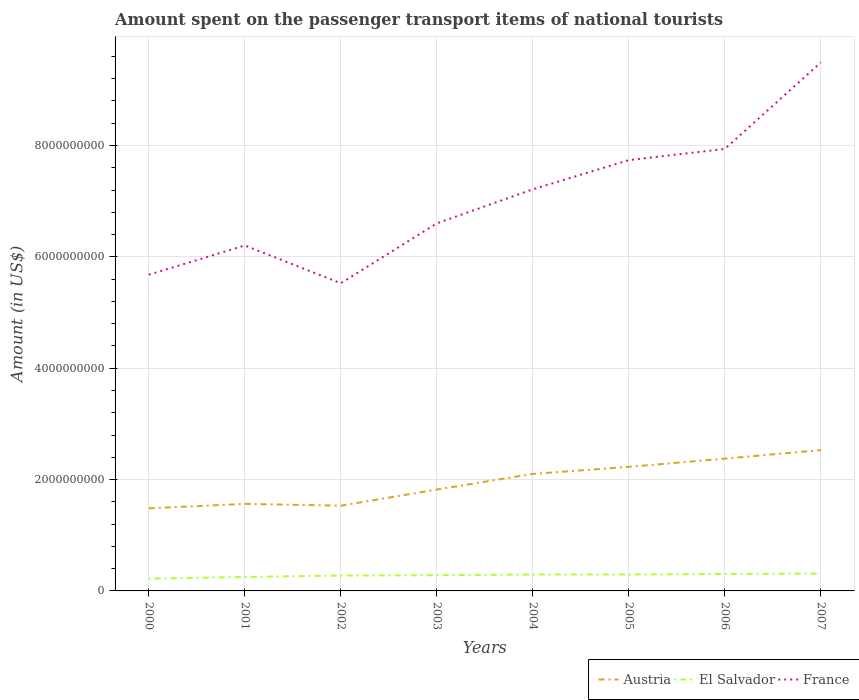How many different coloured lines are there?
Ensure brevity in your answer.  3. Is the number of lines equal to the number of legend labels?
Your response must be concise. Yes. Across all years, what is the maximum amount spent on the passenger transport items of national tourists in El Salvador?
Offer a very short reply. 2.20e+08. What is the total amount spent on the passenger transport items of national tourists in Austria in the graph?
Make the answer very short. -2.75e+08. What is the difference between the highest and the second highest amount spent on the passenger transport items of national tourists in France?
Your answer should be very brief. 3.97e+09. What is the difference between the highest and the lowest amount spent on the passenger transport items of national tourists in Austria?
Keep it short and to the point. 4. How many lines are there?
Give a very brief answer. 3. Are the values on the major ticks of Y-axis written in scientific E-notation?
Ensure brevity in your answer.  No. Where does the legend appear in the graph?
Make the answer very short. Bottom right. How many legend labels are there?
Make the answer very short. 3. What is the title of the graph?
Your response must be concise. Amount spent on the passenger transport items of national tourists. Does "Heavily indebted poor countries" appear as one of the legend labels in the graph?
Your answer should be compact. No. What is the Amount (in US$) in Austria in 2000?
Your answer should be very brief. 1.48e+09. What is the Amount (in US$) of El Salvador in 2000?
Provide a short and direct response. 2.20e+08. What is the Amount (in US$) of France in 2000?
Offer a very short reply. 5.68e+09. What is the Amount (in US$) of Austria in 2001?
Make the answer very short. 1.56e+09. What is the Amount (in US$) of El Salvador in 2001?
Provide a short and direct response. 2.51e+08. What is the Amount (in US$) of France in 2001?
Ensure brevity in your answer.  6.20e+09. What is the Amount (in US$) of Austria in 2002?
Your response must be concise. 1.53e+09. What is the Amount (in US$) in El Salvador in 2002?
Ensure brevity in your answer.  2.76e+08. What is the Amount (in US$) in France in 2002?
Provide a succinct answer. 5.53e+09. What is the Amount (in US$) in Austria in 2003?
Ensure brevity in your answer.  1.82e+09. What is the Amount (in US$) in El Salvador in 2003?
Provide a short and direct response. 2.82e+08. What is the Amount (in US$) in France in 2003?
Give a very brief answer. 6.60e+09. What is the Amount (in US$) of Austria in 2004?
Offer a very short reply. 2.10e+09. What is the Amount (in US$) in El Salvador in 2004?
Your answer should be very brief. 2.95e+08. What is the Amount (in US$) in France in 2004?
Offer a very short reply. 7.21e+09. What is the Amount (in US$) of Austria in 2005?
Your answer should be very brief. 2.23e+09. What is the Amount (in US$) of El Salvador in 2005?
Ensure brevity in your answer.  2.95e+08. What is the Amount (in US$) of France in 2005?
Your response must be concise. 7.74e+09. What is the Amount (in US$) in Austria in 2006?
Provide a short and direct response. 2.38e+09. What is the Amount (in US$) in El Salvador in 2006?
Ensure brevity in your answer.  3.04e+08. What is the Amount (in US$) in France in 2006?
Provide a succinct answer. 7.94e+09. What is the Amount (in US$) in Austria in 2007?
Your answer should be very brief. 2.53e+09. What is the Amount (in US$) of El Salvador in 2007?
Keep it short and to the point. 3.11e+08. What is the Amount (in US$) in France in 2007?
Give a very brief answer. 9.49e+09. Across all years, what is the maximum Amount (in US$) in Austria?
Your response must be concise. 2.53e+09. Across all years, what is the maximum Amount (in US$) of El Salvador?
Provide a short and direct response. 3.11e+08. Across all years, what is the maximum Amount (in US$) in France?
Your response must be concise. 9.49e+09. Across all years, what is the minimum Amount (in US$) in Austria?
Your response must be concise. 1.48e+09. Across all years, what is the minimum Amount (in US$) in El Salvador?
Provide a short and direct response. 2.20e+08. Across all years, what is the minimum Amount (in US$) of France?
Give a very brief answer. 5.53e+09. What is the total Amount (in US$) in Austria in the graph?
Your response must be concise. 1.56e+1. What is the total Amount (in US$) of El Salvador in the graph?
Your response must be concise. 2.23e+09. What is the total Amount (in US$) of France in the graph?
Offer a very short reply. 5.64e+1. What is the difference between the Amount (in US$) of Austria in 2000 and that in 2001?
Offer a very short reply. -8.00e+07. What is the difference between the Amount (in US$) in El Salvador in 2000 and that in 2001?
Keep it short and to the point. -3.10e+07. What is the difference between the Amount (in US$) in France in 2000 and that in 2001?
Provide a short and direct response. -5.25e+08. What is the difference between the Amount (in US$) in Austria in 2000 and that in 2002?
Make the answer very short. -4.80e+07. What is the difference between the Amount (in US$) of El Salvador in 2000 and that in 2002?
Provide a succinct answer. -5.60e+07. What is the difference between the Amount (in US$) in France in 2000 and that in 2002?
Make the answer very short. 1.53e+08. What is the difference between the Amount (in US$) in Austria in 2000 and that in 2003?
Your answer should be very brief. -3.38e+08. What is the difference between the Amount (in US$) in El Salvador in 2000 and that in 2003?
Your answer should be very brief. -6.20e+07. What is the difference between the Amount (in US$) of France in 2000 and that in 2003?
Ensure brevity in your answer.  -9.22e+08. What is the difference between the Amount (in US$) in Austria in 2000 and that in 2004?
Give a very brief answer. -6.18e+08. What is the difference between the Amount (in US$) of El Salvador in 2000 and that in 2004?
Offer a terse response. -7.50e+07. What is the difference between the Amount (in US$) of France in 2000 and that in 2004?
Offer a terse response. -1.53e+09. What is the difference between the Amount (in US$) in Austria in 2000 and that in 2005?
Provide a short and direct response. -7.45e+08. What is the difference between the Amount (in US$) of El Salvador in 2000 and that in 2005?
Offer a very short reply. -7.50e+07. What is the difference between the Amount (in US$) of France in 2000 and that in 2005?
Give a very brief answer. -2.06e+09. What is the difference between the Amount (in US$) in Austria in 2000 and that in 2006?
Provide a short and direct response. -8.93e+08. What is the difference between the Amount (in US$) in El Salvador in 2000 and that in 2006?
Give a very brief answer. -8.40e+07. What is the difference between the Amount (in US$) of France in 2000 and that in 2006?
Offer a terse response. -2.26e+09. What is the difference between the Amount (in US$) of Austria in 2000 and that in 2007?
Keep it short and to the point. -1.05e+09. What is the difference between the Amount (in US$) in El Salvador in 2000 and that in 2007?
Keep it short and to the point. -9.10e+07. What is the difference between the Amount (in US$) of France in 2000 and that in 2007?
Offer a very short reply. -3.81e+09. What is the difference between the Amount (in US$) in Austria in 2001 and that in 2002?
Your answer should be compact. 3.20e+07. What is the difference between the Amount (in US$) of El Salvador in 2001 and that in 2002?
Offer a terse response. -2.50e+07. What is the difference between the Amount (in US$) of France in 2001 and that in 2002?
Give a very brief answer. 6.78e+08. What is the difference between the Amount (in US$) of Austria in 2001 and that in 2003?
Your response must be concise. -2.58e+08. What is the difference between the Amount (in US$) of El Salvador in 2001 and that in 2003?
Your response must be concise. -3.10e+07. What is the difference between the Amount (in US$) of France in 2001 and that in 2003?
Make the answer very short. -3.97e+08. What is the difference between the Amount (in US$) in Austria in 2001 and that in 2004?
Provide a short and direct response. -5.38e+08. What is the difference between the Amount (in US$) in El Salvador in 2001 and that in 2004?
Provide a succinct answer. -4.40e+07. What is the difference between the Amount (in US$) in France in 2001 and that in 2004?
Keep it short and to the point. -1.01e+09. What is the difference between the Amount (in US$) of Austria in 2001 and that in 2005?
Your response must be concise. -6.65e+08. What is the difference between the Amount (in US$) in El Salvador in 2001 and that in 2005?
Make the answer very short. -4.40e+07. What is the difference between the Amount (in US$) of France in 2001 and that in 2005?
Ensure brevity in your answer.  -1.53e+09. What is the difference between the Amount (in US$) in Austria in 2001 and that in 2006?
Your answer should be compact. -8.13e+08. What is the difference between the Amount (in US$) of El Salvador in 2001 and that in 2006?
Your answer should be compact. -5.30e+07. What is the difference between the Amount (in US$) in France in 2001 and that in 2006?
Give a very brief answer. -1.73e+09. What is the difference between the Amount (in US$) of Austria in 2001 and that in 2007?
Your response must be concise. -9.66e+08. What is the difference between the Amount (in US$) of El Salvador in 2001 and that in 2007?
Your answer should be compact. -6.00e+07. What is the difference between the Amount (in US$) of France in 2001 and that in 2007?
Provide a short and direct response. -3.29e+09. What is the difference between the Amount (in US$) in Austria in 2002 and that in 2003?
Offer a terse response. -2.90e+08. What is the difference between the Amount (in US$) of El Salvador in 2002 and that in 2003?
Give a very brief answer. -6.00e+06. What is the difference between the Amount (in US$) in France in 2002 and that in 2003?
Give a very brief answer. -1.08e+09. What is the difference between the Amount (in US$) of Austria in 2002 and that in 2004?
Offer a terse response. -5.70e+08. What is the difference between the Amount (in US$) in El Salvador in 2002 and that in 2004?
Provide a short and direct response. -1.90e+07. What is the difference between the Amount (in US$) in France in 2002 and that in 2004?
Offer a terse response. -1.69e+09. What is the difference between the Amount (in US$) in Austria in 2002 and that in 2005?
Your answer should be very brief. -6.97e+08. What is the difference between the Amount (in US$) of El Salvador in 2002 and that in 2005?
Your response must be concise. -1.90e+07. What is the difference between the Amount (in US$) in France in 2002 and that in 2005?
Your answer should be compact. -2.21e+09. What is the difference between the Amount (in US$) in Austria in 2002 and that in 2006?
Offer a very short reply. -8.45e+08. What is the difference between the Amount (in US$) of El Salvador in 2002 and that in 2006?
Make the answer very short. -2.80e+07. What is the difference between the Amount (in US$) of France in 2002 and that in 2006?
Provide a short and direct response. -2.41e+09. What is the difference between the Amount (in US$) in Austria in 2002 and that in 2007?
Your answer should be compact. -9.98e+08. What is the difference between the Amount (in US$) in El Salvador in 2002 and that in 2007?
Offer a terse response. -3.50e+07. What is the difference between the Amount (in US$) in France in 2002 and that in 2007?
Provide a short and direct response. -3.97e+09. What is the difference between the Amount (in US$) in Austria in 2003 and that in 2004?
Provide a short and direct response. -2.80e+08. What is the difference between the Amount (in US$) of El Salvador in 2003 and that in 2004?
Offer a very short reply. -1.30e+07. What is the difference between the Amount (in US$) of France in 2003 and that in 2004?
Offer a terse response. -6.12e+08. What is the difference between the Amount (in US$) of Austria in 2003 and that in 2005?
Provide a short and direct response. -4.07e+08. What is the difference between the Amount (in US$) in El Salvador in 2003 and that in 2005?
Ensure brevity in your answer.  -1.30e+07. What is the difference between the Amount (in US$) in France in 2003 and that in 2005?
Provide a short and direct response. -1.14e+09. What is the difference between the Amount (in US$) in Austria in 2003 and that in 2006?
Offer a terse response. -5.55e+08. What is the difference between the Amount (in US$) of El Salvador in 2003 and that in 2006?
Your response must be concise. -2.20e+07. What is the difference between the Amount (in US$) in France in 2003 and that in 2006?
Ensure brevity in your answer.  -1.34e+09. What is the difference between the Amount (in US$) of Austria in 2003 and that in 2007?
Ensure brevity in your answer.  -7.08e+08. What is the difference between the Amount (in US$) of El Salvador in 2003 and that in 2007?
Offer a very short reply. -2.90e+07. What is the difference between the Amount (in US$) of France in 2003 and that in 2007?
Provide a succinct answer. -2.89e+09. What is the difference between the Amount (in US$) of Austria in 2004 and that in 2005?
Your answer should be compact. -1.27e+08. What is the difference between the Amount (in US$) of El Salvador in 2004 and that in 2005?
Your answer should be compact. 0. What is the difference between the Amount (in US$) in France in 2004 and that in 2005?
Offer a terse response. -5.24e+08. What is the difference between the Amount (in US$) in Austria in 2004 and that in 2006?
Provide a succinct answer. -2.75e+08. What is the difference between the Amount (in US$) in El Salvador in 2004 and that in 2006?
Your response must be concise. -9.00e+06. What is the difference between the Amount (in US$) of France in 2004 and that in 2006?
Keep it short and to the point. -7.25e+08. What is the difference between the Amount (in US$) in Austria in 2004 and that in 2007?
Your answer should be very brief. -4.28e+08. What is the difference between the Amount (in US$) in El Salvador in 2004 and that in 2007?
Provide a short and direct response. -1.60e+07. What is the difference between the Amount (in US$) of France in 2004 and that in 2007?
Your response must be concise. -2.28e+09. What is the difference between the Amount (in US$) in Austria in 2005 and that in 2006?
Provide a short and direct response. -1.48e+08. What is the difference between the Amount (in US$) in El Salvador in 2005 and that in 2006?
Keep it short and to the point. -9.00e+06. What is the difference between the Amount (in US$) of France in 2005 and that in 2006?
Your answer should be very brief. -2.01e+08. What is the difference between the Amount (in US$) of Austria in 2005 and that in 2007?
Give a very brief answer. -3.01e+08. What is the difference between the Amount (in US$) in El Salvador in 2005 and that in 2007?
Make the answer very short. -1.60e+07. What is the difference between the Amount (in US$) in France in 2005 and that in 2007?
Offer a very short reply. -1.76e+09. What is the difference between the Amount (in US$) of Austria in 2006 and that in 2007?
Give a very brief answer. -1.53e+08. What is the difference between the Amount (in US$) in El Salvador in 2006 and that in 2007?
Your answer should be compact. -7.00e+06. What is the difference between the Amount (in US$) of France in 2006 and that in 2007?
Make the answer very short. -1.55e+09. What is the difference between the Amount (in US$) of Austria in 2000 and the Amount (in US$) of El Salvador in 2001?
Keep it short and to the point. 1.23e+09. What is the difference between the Amount (in US$) of Austria in 2000 and the Amount (in US$) of France in 2001?
Your response must be concise. -4.72e+09. What is the difference between the Amount (in US$) in El Salvador in 2000 and the Amount (in US$) in France in 2001?
Your response must be concise. -5.98e+09. What is the difference between the Amount (in US$) of Austria in 2000 and the Amount (in US$) of El Salvador in 2002?
Keep it short and to the point. 1.21e+09. What is the difference between the Amount (in US$) of Austria in 2000 and the Amount (in US$) of France in 2002?
Offer a very short reply. -4.04e+09. What is the difference between the Amount (in US$) in El Salvador in 2000 and the Amount (in US$) in France in 2002?
Ensure brevity in your answer.  -5.31e+09. What is the difference between the Amount (in US$) of Austria in 2000 and the Amount (in US$) of El Salvador in 2003?
Offer a terse response. 1.20e+09. What is the difference between the Amount (in US$) of Austria in 2000 and the Amount (in US$) of France in 2003?
Give a very brief answer. -5.12e+09. What is the difference between the Amount (in US$) in El Salvador in 2000 and the Amount (in US$) in France in 2003?
Offer a very short reply. -6.38e+09. What is the difference between the Amount (in US$) of Austria in 2000 and the Amount (in US$) of El Salvador in 2004?
Provide a short and direct response. 1.19e+09. What is the difference between the Amount (in US$) in Austria in 2000 and the Amount (in US$) in France in 2004?
Keep it short and to the point. -5.73e+09. What is the difference between the Amount (in US$) in El Salvador in 2000 and the Amount (in US$) in France in 2004?
Keep it short and to the point. -6.99e+09. What is the difference between the Amount (in US$) of Austria in 2000 and the Amount (in US$) of El Salvador in 2005?
Provide a short and direct response. 1.19e+09. What is the difference between the Amount (in US$) in Austria in 2000 and the Amount (in US$) in France in 2005?
Ensure brevity in your answer.  -6.25e+09. What is the difference between the Amount (in US$) of El Salvador in 2000 and the Amount (in US$) of France in 2005?
Your response must be concise. -7.52e+09. What is the difference between the Amount (in US$) of Austria in 2000 and the Amount (in US$) of El Salvador in 2006?
Make the answer very short. 1.18e+09. What is the difference between the Amount (in US$) of Austria in 2000 and the Amount (in US$) of France in 2006?
Offer a very short reply. -6.46e+09. What is the difference between the Amount (in US$) of El Salvador in 2000 and the Amount (in US$) of France in 2006?
Keep it short and to the point. -7.72e+09. What is the difference between the Amount (in US$) in Austria in 2000 and the Amount (in US$) in El Salvador in 2007?
Your response must be concise. 1.17e+09. What is the difference between the Amount (in US$) in Austria in 2000 and the Amount (in US$) in France in 2007?
Your answer should be very brief. -8.01e+09. What is the difference between the Amount (in US$) of El Salvador in 2000 and the Amount (in US$) of France in 2007?
Your response must be concise. -9.27e+09. What is the difference between the Amount (in US$) in Austria in 2001 and the Amount (in US$) in El Salvador in 2002?
Give a very brief answer. 1.29e+09. What is the difference between the Amount (in US$) of Austria in 2001 and the Amount (in US$) of France in 2002?
Provide a succinct answer. -3.96e+09. What is the difference between the Amount (in US$) of El Salvador in 2001 and the Amount (in US$) of France in 2002?
Keep it short and to the point. -5.28e+09. What is the difference between the Amount (in US$) in Austria in 2001 and the Amount (in US$) in El Salvador in 2003?
Offer a very short reply. 1.28e+09. What is the difference between the Amount (in US$) in Austria in 2001 and the Amount (in US$) in France in 2003?
Provide a short and direct response. -5.04e+09. What is the difference between the Amount (in US$) in El Salvador in 2001 and the Amount (in US$) in France in 2003?
Provide a short and direct response. -6.35e+09. What is the difference between the Amount (in US$) of Austria in 2001 and the Amount (in US$) of El Salvador in 2004?
Your answer should be very brief. 1.27e+09. What is the difference between the Amount (in US$) of Austria in 2001 and the Amount (in US$) of France in 2004?
Your answer should be compact. -5.65e+09. What is the difference between the Amount (in US$) of El Salvador in 2001 and the Amount (in US$) of France in 2004?
Give a very brief answer. -6.96e+09. What is the difference between the Amount (in US$) in Austria in 2001 and the Amount (in US$) in El Salvador in 2005?
Your answer should be compact. 1.27e+09. What is the difference between the Amount (in US$) in Austria in 2001 and the Amount (in US$) in France in 2005?
Give a very brief answer. -6.17e+09. What is the difference between the Amount (in US$) of El Salvador in 2001 and the Amount (in US$) of France in 2005?
Give a very brief answer. -7.49e+09. What is the difference between the Amount (in US$) in Austria in 2001 and the Amount (in US$) in El Salvador in 2006?
Ensure brevity in your answer.  1.26e+09. What is the difference between the Amount (in US$) of Austria in 2001 and the Amount (in US$) of France in 2006?
Keep it short and to the point. -6.38e+09. What is the difference between the Amount (in US$) in El Salvador in 2001 and the Amount (in US$) in France in 2006?
Your response must be concise. -7.69e+09. What is the difference between the Amount (in US$) of Austria in 2001 and the Amount (in US$) of El Salvador in 2007?
Ensure brevity in your answer.  1.25e+09. What is the difference between the Amount (in US$) in Austria in 2001 and the Amount (in US$) in France in 2007?
Provide a succinct answer. -7.93e+09. What is the difference between the Amount (in US$) of El Salvador in 2001 and the Amount (in US$) of France in 2007?
Ensure brevity in your answer.  -9.24e+09. What is the difference between the Amount (in US$) in Austria in 2002 and the Amount (in US$) in El Salvador in 2003?
Provide a short and direct response. 1.25e+09. What is the difference between the Amount (in US$) in Austria in 2002 and the Amount (in US$) in France in 2003?
Ensure brevity in your answer.  -5.07e+09. What is the difference between the Amount (in US$) in El Salvador in 2002 and the Amount (in US$) in France in 2003?
Your answer should be compact. -6.32e+09. What is the difference between the Amount (in US$) in Austria in 2002 and the Amount (in US$) in El Salvador in 2004?
Provide a short and direct response. 1.24e+09. What is the difference between the Amount (in US$) in Austria in 2002 and the Amount (in US$) in France in 2004?
Make the answer very short. -5.68e+09. What is the difference between the Amount (in US$) of El Salvador in 2002 and the Amount (in US$) of France in 2004?
Ensure brevity in your answer.  -6.94e+09. What is the difference between the Amount (in US$) of Austria in 2002 and the Amount (in US$) of El Salvador in 2005?
Give a very brief answer. 1.24e+09. What is the difference between the Amount (in US$) in Austria in 2002 and the Amount (in US$) in France in 2005?
Provide a succinct answer. -6.21e+09. What is the difference between the Amount (in US$) in El Salvador in 2002 and the Amount (in US$) in France in 2005?
Your answer should be compact. -7.46e+09. What is the difference between the Amount (in US$) of Austria in 2002 and the Amount (in US$) of El Salvador in 2006?
Provide a succinct answer. 1.23e+09. What is the difference between the Amount (in US$) in Austria in 2002 and the Amount (in US$) in France in 2006?
Ensure brevity in your answer.  -6.41e+09. What is the difference between the Amount (in US$) in El Salvador in 2002 and the Amount (in US$) in France in 2006?
Your response must be concise. -7.66e+09. What is the difference between the Amount (in US$) of Austria in 2002 and the Amount (in US$) of El Salvador in 2007?
Provide a short and direct response. 1.22e+09. What is the difference between the Amount (in US$) of Austria in 2002 and the Amount (in US$) of France in 2007?
Offer a terse response. -7.96e+09. What is the difference between the Amount (in US$) in El Salvador in 2002 and the Amount (in US$) in France in 2007?
Offer a terse response. -9.22e+09. What is the difference between the Amount (in US$) of Austria in 2003 and the Amount (in US$) of El Salvador in 2004?
Your answer should be very brief. 1.53e+09. What is the difference between the Amount (in US$) of Austria in 2003 and the Amount (in US$) of France in 2004?
Provide a succinct answer. -5.39e+09. What is the difference between the Amount (in US$) of El Salvador in 2003 and the Amount (in US$) of France in 2004?
Make the answer very short. -6.93e+09. What is the difference between the Amount (in US$) of Austria in 2003 and the Amount (in US$) of El Salvador in 2005?
Your answer should be compact. 1.53e+09. What is the difference between the Amount (in US$) of Austria in 2003 and the Amount (in US$) of France in 2005?
Provide a succinct answer. -5.92e+09. What is the difference between the Amount (in US$) in El Salvador in 2003 and the Amount (in US$) in France in 2005?
Your answer should be compact. -7.46e+09. What is the difference between the Amount (in US$) in Austria in 2003 and the Amount (in US$) in El Salvador in 2006?
Your response must be concise. 1.52e+09. What is the difference between the Amount (in US$) in Austria in 2003 and the Amount (in US$) in France in 2006?
Offer a very short reply. -6.12e+09. What is the difference between the Amount (in US$) in El Salvador in 2003 and the Amount (in US$) in France in 2006?
Offer a terse response. -7.66e+09. What is the difference between the Amount (in US$) in Austria in 2003 and the Amount (in US$) in El Salvador in 2007?
Your answer should be very brief. 1.51e+09. What is the difference between the Amount (in US$) of Austria in 2003 and the Amount (in US$) of France in 2007?
Your answer should be very brief. -7.67e+09. What is the difference between the Amount (in US$) of El Salvador in 2003 and the Amount (in US$) of France in 2007?
Provide a short and direct response. -9.21e+09. What is the difference between the Amount (in US$) of Austria in 2004 and the Amount (in US$) of El Salvador in 2005?
Give a very brief answer. 1.81e+09. What is the difference between the Amount (in US$) in Austria in 2004 and the Amount (in US$) in France in 2005?
Provide a short and direct response. -5.64e+09. What is the difference between the Amount (in US$) of El Salvador in 2004 and the Amount (in US$) of France in 2005?
Your response must be concise. -7.44e+09. What is the difference between the Amount (in US$) in Austria in 2004 and the Amount (in US$) in El Salvador in 2006?
Your answer should be compact. 1.80e+09. What is the difference between the Amount (in US$) in Austria in 2004 and the Amount (in US$) in France in 2006?
Keep it short and to the point. -5.84e+09. What is the difference between the Amount (in US$) in El Salvador in 2004 and the Amount (in US$) in France in 2006?
Your response must be concise. -7.64e+09. What is the difference between the Amount (in US$) in Austria in 2004 and the Amount (in US$) in El Salvador in 2007?
Provide a short and direct response. 1.79e+09. What is the difference between the Amount (in US$) of Austria in 2004 and the Amount (in US$) of France in 2007?
Offer a terse response. -7.39e+09. What is the difference between the Amount (in US$) in El Salvador in 2004 and the Amount (in US$) in France in 2007?
Give a very brief answer. -9.20e+09. What is the difference between the Amount (in US$) of Austria in 2005 and the Amount (in US$) of El Salvador in 2006?
Make the answer very short. 1.92e+09. What is the difference between the Amount (in US$) of Austria in 2005 and the Amount (in US$) of France in 2006?
Provide a short and direct response. -5.71e+09. What is the difference between the Amount (in US$) in El Salvador in 2005 and the Amount (in US$) in France in 2006?
Provide a short and direct response. -7.64e+09. What is the difference between the Amount (in US$) in Austria in 2005 and the Amount (in US$) in El Salvador in 2007?
Your response must be concise. 1.92e+09. What is the difference between the Amount (in US$) of Austria in 2005 and the Amount (in US$) of France in 2007?
Keep it short and to the point. -7.26e+09. What is the difference between the Amount (in US$) of El Salvador in 2005 and the Amount (in US$) of France in 2007?
Keep it short and to the point. -9.20e+09. What is the difference between the Amount (in US$) in Austria in 2006 and the Amount (in US$) in El Salvador in 2007?
Provide a short and direct response. 2.06e+09. What is the difference between the Amount (in US$) of Austria in 2006 and the Amount (in US$) of France in 2007?
Ensure brevity in your answer.  -7.12e+09. What is the difference between the Amount (in US$) of El Salvador in 2006 and the Amount (in US$) of France in 2007?
Give a very brief answer. -9.19e+09. What is the average Amount (in US$) in Austria per year?
Your answer should be very brief. 1.95e+09. What is the average Amount (in US$) of El Salvador per year?
Your response must be concise. 2.79e+08. What is the average Amount (in US$) in France per year?
Make the answer very short. 7.05e+09. In the year 2000, what is the difference between the Amount (in US$) in Austria and Amount (in US$) in El Salvador?
Ensure brevity in your answer.  1.26e+09. In the year 2000, what is the difference between the Amount (in US$) in Austria and Amount (in US$) in France?
Keep it short and to the point. -4.20e+09. In the year 2000, what is the difference between the Amount (in US$) in El Salvador and Amount (in US$) in France?
Give a very brief answer. -5.46e+09. In the year 2001, what is the difference between the Amount (in US$) in Austria and Amount (in US$) in El Salvador?
Offer a terse response. 1.31e+09. In the year 2001, what is the difference between the Amount (in US$) in Austria and Amount (in US$) in France?
Your answer should be compact. -4.64e+09. In the year 2001, what is the difference between the Amount (in US$) of El Salvador and Amount (in US$) of France?
Provide a short and direct response. -5.95e+09. In the year 2002, what is the difference between the Amount (in US$) of Austria and Amount (in US$) of El Salvador?
Give a very brief answer. 1.26e+09. In the year 2002, what is the difference between the Amount (in US$) in Austria and Amount (in US$) in France?
Ensure brevity in your answer.  -4.00e+09. In the year 2002, what is the difference between the Amount (in US$) in El Salvador and Amount (in US$) in France?
Offer a terse response. -5.25e+09. In the year 2003, what is the difference between the Amount (in US$) in Austria and Amount (in US$) in El Salvador?
Offer a very short reply. 1.54e+09. In the year 2003, what is the difference between the Amount (in US$) in Austria and Amount (in US$) in France?
Offer a very short reply. -4.78e+09. In the year 2003, what is the difference between the Amount (in US$) of El Salvador and Amount (in US$) of France?
Provide a succinct answer. -6.32e+09. In the year 2004, what is the difference between the Amount (in US$) of Austria and Amount (in US$) of El Salvador?
Your answer should be compact. 1.81e+09. In the year 2004, what is the difference between the Amount (in US$) in Austria and Amount (in US$) in France?
Your answer should be very brief. -5.11e+09. In the year 2004, what is the difference between the Amount (in US$) of El Salvador and Amount (in US$) of France?
Your response must be concise. -6.92e+09. In the year 2005, what is the difference between the Amount (in US$) of Austria and Amount (in US$) of El Salvador?
Provide a short and direct response. 1.93e+09. In the year 2005, what is the difference between the Amount (in US$) in Austria and Amount (in US$) in France?
Provide a succinct answer. -5.51e+09. In the year 2005, what is the difference between the Amount (in US$) in El Salvador and Amount (in US$) in France?
Give a very brief answer. -7.44e+09. In the year 2006, what is the difference between the Amount (in US$) of Austria and Amount (in US$) of El Salvador?
Your answer should be very brief. 2.07e+09. In the year 2006, what is the difference between the Amount (in US$) in Austria and Amount (in US$) in France?
Provide a short and direct response. -5.56e+09. In the year 2006, what is the difference between the Amount (in US$) in El Salvador and Amount (in US$) in France?
Make the answer very short. -7.63e+09. In the year 2007, what is the difference between the Amount (in US$) of Austria and Amount (in US$) of El Salvador?
Offer a very short reply. 2.22e+09. In the year 2007, what is the difference between the Amount (in US$) in Austria and Amount (in US$) in France?
Provide a short and direct response. -6.96e+09. In the year 2007, what is the difference between the Amount (in US$) in El Salvador and Amount (in US$) in France?
Your answer should be very brief. -9.18e+09. What is the ratio of the Amount (in US$) of Austria in 2000 to that in 2001?
Give a very brief answer. 0.95. What is the ratio of the Amount (in US$) of El Salvador in 2000 to that in 2001?
Ensure brevity in your answer.  0.88. What is the ratio of the Amount (in US$) of France in 2000 to that in 2001?
Provide a succinct answer. 0.92. What is the ratio of the Amount (in US$) of Austria in 2000 to that in 2002?
Your answer should be compact. 0.97. What is the ratio of the Amount (in US$) of El Salvador in 2000 to that in 2002?
Ensure brevity in your answer.  0.8. What is the ratio of the Amount (in US$) in France in 2000 to that in 2002?
Offer a terse response. 1.03. What is the ratio of the Amount (in US$) in Austria in 2000 to that in 2003?
Offer a terse response. 0.81. What is the ratio of the Amount (in US$) of El Salvador in 2000 to that in 2003?
Make the answer very short. 0.78. What is the ratio of the Amount (in US$) in France in 2000 to that in 2003?
Ensure brevity in your answer.  0.86. What is the ratio of the Amount (in US$) in Austria in 2000 to that in 2004?
Provide a short and direct response. 0.71. What is the ratio of the Amount (in US$) of El Salvador in 2000 to that in 2004?
Your answer should be very brief. 0.75. What is the ratio of the Amount (in US$) in France in 2000 to that in 2004?
Your response must be concise. 0.79. What is the ratio of the Amount (in US$) of Austria in 2000 to that in 2005?
Your answer should be compact. 0.67. What is the ratio of the Amount (in US$) of El Salvador in 2000 to that in 2005?
Offer a very short reply. 0.75. What is the ratio of the Amount (in US$) in France in 2000 to that in 2005?
Provide a succinct answer. 0.73. What is the ratio of the Amount (in US$) of Austria in 2000 to that in 2006?
Your response must be concise. 0.62. What is the ratio of the Amount (in US$) in El Salvador in 2000 to that in 2006?
Ensure brevity in your answer.  0.72. What is the ratio of the Amount (in US$) in France in 2000 to that in 2006?
Make the answer very short. 0.72. What is the ratio of the Amount (in US$) of Austria in 2000 to that in 2007?
Give a very brief answer. 0.59. What is the ratio of the Amount (in US$) in El Salvador in 2000 to that in 2007?
Make the answer very short. 0.71. What is the ratio of the Amount (in US$) of France in 2000 to that in 2007?
Your answer should be compact. 0.6. What is the ratio of the Amount (in US$) in Austria in 2001 to that in 2002?
Your response must be concise. 1.02. What is the ratio of the Amount (in US$) of El Salvador in 2001 to that in 2002?
Ensure brevity in your answer.  0.91. What is the ratio of the Amount (in US$) in France in 2001 to that in 2002?
Your answer should be compact. 1.12. What is the ratio of the Amount (in US$) in Austria in 2001 to that in 2003?
Give a very brief answer. 0.86. What is the ratio of the Amount (in US$) in El Salvador in 2001 to that in 2003?
Provide a short and direct response. 0.89. What is the ratio of the Amount (in US$) of France in 2001 to that in 2003?
Give a very brief answer. 0.94. What is the ratio of the Amount (in US$) in Austria in 2001 to that in 2004?
Your response must be concise. 0.74. What is the ratio of the Amount (in US$) in El Salvador in 2001 to that in 2004?
Offer a terse response. 0.85. What is the ratio of the Amount (in US$) of France in 2001 to that in 2004?
Offer a very short reply. 0.86. What is the ratio of the Amount (in US$) in Austria in 2001 to that in 2005?
Your response must be concise. 0.7. What is the ratio of the Amount (in US$) in El Salvador in 2001 to that in 2005?
Provide a short and direct response. 0.85. What is the ratio of the Amount (in US$) of France in 2001 to that in 2005?
Ensure brevity in your answer.  0.8. What is the ratio of the Amount (in US$) of Austria in 2001 to that in 2006?
Provide a short and direct response. 0.66. What is the ratio of the Amount (in US$) in El Salvador in 2001 to that in 2006?
Your answer should be compact. 0.83. What is the ratio of the Amount (in US$) of France in 2001 to that in 2006?
Your response must be concise. 0.78. What is the ratio of the Amount (in US$) in Austria in 2001 to that in 2007?
Your answer should be compact. 0.62. What is the ratio of the Amount (in US$) of El Salvador in 2001 to that in 2007?
Provide a short and direct response. 0.81. What is the ratio of the Amount (in US$) of France in 2001 to that in 2007?
Offer a very short reply. 0.65. What is the ratio of the Amount (in US$) in Austria in 2002 to that in 2003?
Keep it short and to the point. 0.84. What is the ratio of the Amount (in US$) in El Salvador in 2002 to that in 2003?
Your response must be concise. 0.98. What is the ratio of the Amount (in US$) of France in 2002 to that in 2003?
Provide a succinct answer. 0.84. What is the ratio of the Amount (in US$) of Austria in 2002 to that in 2004?
Offer a terse response. 0.73. What is the ratio of the Amount (in US$) of El Salvador in 2002 to that in 2004?
Offer a very short reply. 0.94. What is the ratio of the Amount (in US$) of France in 2002 to that in 2004?
Provide a succinct answer. 0.77. What is the ratio of the Amount (in US$) of Austria in 2002 to that in 2005?
Give a very brief answer. 0.69. What is the ratio of the Amount (in US$) of El Salvador in 2002 to that in 2005?
Offer a very short reply. 0.94. What is the ratio of the Amount (in US$) of France in 2002 to that in 2005?
Provide a succinct answer. 0.71. What is the ratio of the Amount (in US$) in Austria in 2002 to that in 2006?
Your answer should be very brief. 0.64. What is the ratio of the Amount (in US$) in El Salvador in 2002 to that in 2006?
Your answer should be very brief. 0.91. What is the ratio of the Amount (in US$) of France in 2002 to that in 2006?
Provide a short and direct response. 0.7. What is the ratio of the Amount (in US$) of Austria in 2002 to that in 2007?
Provide a succinct answer. 0.61. What is the ratio of the Amount (in US$) of El Salvador in 2002 to that in 2007?
Keep it short and to the point. 0.89. What is the ratio of the Amount (in US$) of France in 2002 to that in 2007?
Offer a terse response. 0.58. What is the ratio of the Amount (in US$) in Austria in 2003 to that in 2004?
Make the answer very short. 0.87. What is the ratio of the Amount (in US$) in El Salvador in 2003 to that in 2004?
Provide a succinct answer. 0.96. What is the ratio of the Amount (in US$) of France in 2003 to that in 2004?
Your answer should be compact. 0.92. What is the ratio of the Amount (in US$) of Austria in 2003 to that in 2005?
Give a very brief answer. 0.82. What is the ratio of the Amount (in US$) of El Salvador in 2003 to that in 2005?
Ensure brevity in your answer.  0.96. What is the ratio of the Amount (in US$) of France in 2003 to that in 2005?
Your answer should be compact. 0.85. What is the ratio of the Amount (in US$) of Austria in 2003 to that in 2006?
Your answer should be very brief. 0.77. What is the ratio of the Amount (in US$) in El Salvador in 2003 to that in 2006?
Provide a short and direct response. 0.93. What is the ratio of the Amount (in US$) in France in 2003 to that in 2006?
Offer a very short reply. 0.83. What is the ratio of the Amount (in US$) in Austria in 2003 to that in 2007?
Provide a succinct answer. 0.72. What is the ratio of the Amount (in US$) in El Salvador in 2003 to that in 2007?
Offer a terse response. 0.91. What is the ratio of the Amount (in US$) of France in 2003 to that in 2007?
Ensure brevity in your answer.  0.7. What is the ratio of the Amount (in US$) of Austria in 2004 to that in 2005?
Your response must be concise. 0.94. What is the ratio of the Amount (in US$) in El Salvador in 2004 to that in 2005?
Offer a terse response. 1. What is the ratio of the Amount (in US$) in France in 2004 to that in 2005?
Provide a succinct answer. 0.93. What is the ratio of the Amount (in US$) in Austria in 2004 to that in 2006?
Provide a short and direct response. 0.88. What is the ratio of the Amount (in US$) of El Salvador in 2004 to that in 2006?
Give a very brief answer. 0.97. What is the ratio of the Amount (in US$) in France in 2004 to that in 2006?
Give a very brief answer. 0.91. What is the ratio of the Amount (in US$) of Austria in 2004 to that in 2007?
Give a very brief answer. 0.83. What is the ratio of the Amount (in US$) in El Salvador in 2004 to that in 2007?
Offer a terse response. 0.95. What is the ratio of the Amount (in US$) of France in 2004 to that in 2007?
Your answer should be very brief. 0.76. What is the ratio of the Amount (in US$) of Austria in 2005 to that in 2006?
Make the answer very short. 0.94. What is the ratio of the Amount (in US$) of El Salvador in 2005 to that in 2006?
Ensure brevity in your answer.  0.97. What is the ratio of the Amount (in US$) in France in 2005 to that in 2006?
Provide a succinct answer. 0.97. What is the ratio of the Amount (in US$) in Austria in 2005 to that in 2007?
Make the answer very short. 0.88. What is the ratio of the Amount (in US$) in El Salvador in 2005 to that in 2007?
Provide a short and direct response. 0.95. What is the ratio of the Amount (in US$) of France in 2005 to that in 2007?
Give a very brief answer. 0.82. What is the ratio of the Amount (in US$) of Austria in 2006 to that in 2007?
Provide a succinct answer. 0.94. What is the ratio of the Amount (in US$) in El Salvador in 2006 to that in 2007?
Offer a very short reply. 0.98. What is the ratio of the Amount (in US$) of France in 2006 to that in 2007?
Your response must be concise. 0.84. What is the difference between the highest and the second highest Amount (in US$) of Austria?
Your response must be concise. 1.53e+08. What is the difference between the highest and the second highest Amount (in US$) in France?
Offer a very short reply. 1.55e+09. What is the difference between the highest and the lowest Amount (in US$) of Austria?
Ensure brevity in your answer.  1.05e+09. What is the difference between the highest and the lowest Amount (in US$) of El Salvador?
Ensure brevity in your answer.  9.10e+07. What is the difference between the highest and the lowest Amount (in US$) of France?
Ensure brevity in your answer.  3.97e+09. 